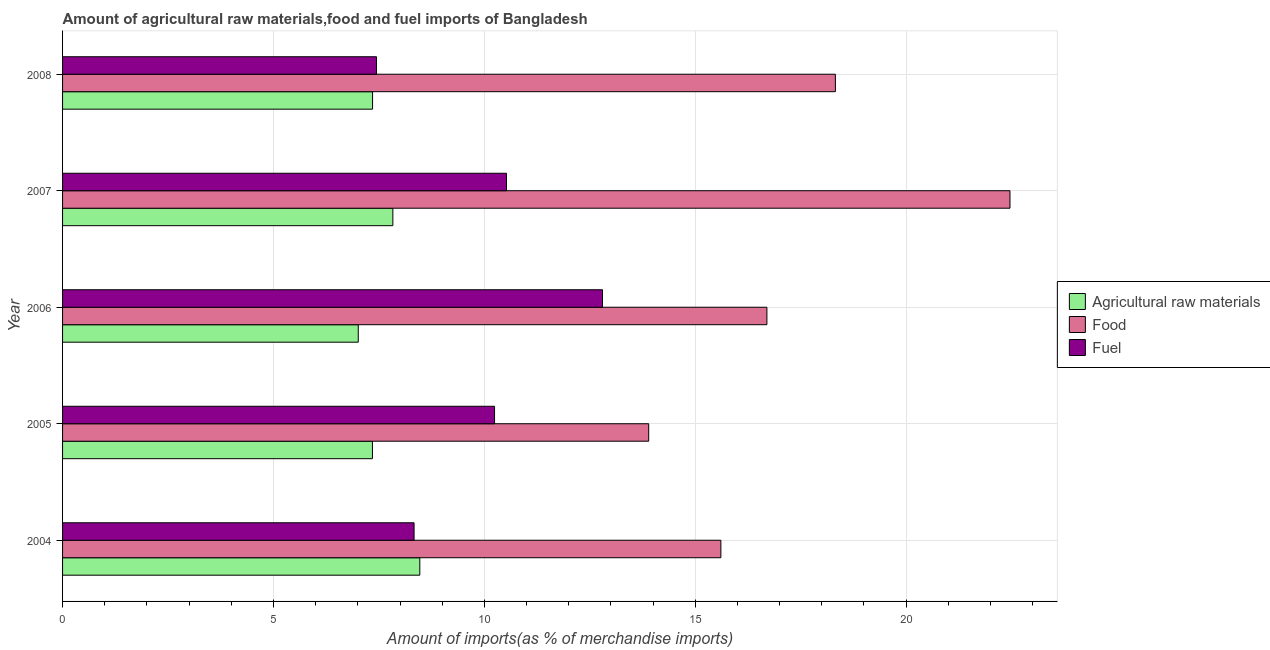How many groups of bars are there?
Provide a short and direct response. 5. Are the number of bars on each tick of the Y-axis equal?
Keep it short and to the point. Yes. How many bars are there on the 5th tick from the top?
Your response must be concise. 3. How many bars are there on the 2nd tick from the bottom?
Provide a short and direct response. 3. What is the label of the 2nd group of bars from the top?
Your response must be concise. 2007. What is the percentage of fuel imports in 2005?
Offer a terse response. 10.24. Across all years, what is the maximum percentage of food imports?
Offer a terse response. 22.46. Across all years, what is the minimum percentage of fuel imports?
Ensure brevity in your answer.  7.44. In which year was the percentage of raw materials imports maximum?
Provide a short and direct response. 2004. What is the total percentage of raw materials imports in the graph?
Keep it short and to the point. 38.01. What is the difference between the percentage of fuel imports in 2005 and that in 2008?
Make the answer very short. 2.8. What is the difference between the percentage of fuel imports in 2004 and the percentage of food imports in 2008?
Provide a succinct answer. -9.99. What is the average percentage of raw materials imports per year?
Your response must be concise. 7.6. In the year 2005, what is the difference between the percentage of fuel imports and percentage of raw materials imports?
Ensure brevity in your answer.  2.9. What is the ratio of the percentage of fuel imports in 2005 to that in 2008?
Your response must be concise. 1.38. Is the difference between the percentage of food imports in 2005 and 2008 greater than the difference between the percentage of fuel imports in 2005 and 2008?
Provide a succinct answer. No. What is the difference between the highest and the second highest percentage of fuel imports?
Provide a short and direct response. 2.28. What is the difference between the highest and the lowest percentage of raw materials imports?
Ensure brevity in your answer.  1.46. In how many years, is the percentage of fuel imports greater than the average percentage of fuel imports taken over all years?
Provide a short and direct response. 3. Is the sum of the percentage of raw materials imports in 2005 and 2008 greater than the maximum percentage of fuel imports across all years?
Keep it short and to the point. Yes. What does the 2nd bar from the top in 2007 represents?
Ensure brevity in your answer.  Food. What does the 2nd bar from the bottom in 2008 represents?
Provide a short and direct response. Food. Is it the case that in every year, the sum of the percentage of raw materials imports and percentage of food imports is greater than the percentage of fuel imports?
Offer a very short reply. Yes. What is the difference between two consecutive major ticks on the X-axis?
Provide a short and direct response. 5. Does the graph contain any zero values?
Make the answer very short. No. Does the graph contain grids?
Make the answer very short. Yes. How are the legend labels stacked?
Your answer should be compact. Vertical. What is the title of the graph?
Your answer should be very brief. Amount of agricultural raw materials,food and fuel imports of Bangladesh. Does "Gaseous fuel" appear as one of the legend labels in the graph?
Your response must be concise. No. What is the label or title of the X-axis?
Give a very brief answer. Amount of imports(as % of merchandise imports). What is the Amount of imports(as % of merchandise imports) in Agricultural raw materials in 2004?
Your answer should be compact. 8.47. What is the Amount of imports(as % of merchandise imports) of Food in 2004?
Offer a very short reply. 15.61. What is the Amount of imports(as % of merchandise imports) of Fuel in 2004?
Offer a terse response. 8.33. What is the Amount of imports(as % of merchandise imports) of Agricultural raw materials in 2005?
Your response must be concise. 7.35. What is the Amount of imports(as % of merchandise imports) in Food in 2005?
Make the answer very short. 13.9. What is the Amount of imports(as % of merchandise imports) in Fuel in 2005?
Provide a short and direct response. 10.24. What is the Amount of imports(as % of merchandise imports) in Agricultural raw materials in 2006?
Provide a short and direct response. 7.01. What is the Amount of imports(as % of merchandise imports) in Food in 2006?
Your answer should be compact. 16.7. What is the Amount of imports(as % of merchandise imports) in Fuel in 2006?
Offer a terse response. 12.8. What is the Amount of imports(as % of merchandise imports) in Agricultural raw materials in 2007?
Offer a terse response. 7.83. What is the Amount of imports(as % of merchandise imports) in Food in 2007?
Make the answer very short. 22.46. What is the Amount of imports(as % of merchandise imports) of Fuel in 2007?
Offer a very short reply. 10.52. What is the Amount of imports(as % of merchandise imports) in Agricultural raw materials in 2008?
Your answer should be very brief. 7.35. What is the Amount of imports(as % of merchandise imports) of Food in 2008?
Provide a succinct answer. 18.32. What is the Amount of imports(as % of merchandise imports) of Fuel in 2008?
Ensure brevity in your answer.  7.44. Across all years, what is the maximum Amount of imports(as % of merchandise imports) in Agricultural raw materials?
Offer a terse response. 8.47. Across all years, what is the maximum Amount of imports(as % of merchandise imports) in Food?
Your answer should be very brief. 22.46. Across all years, what is the maximum Amount of imports(as % of merchandise imports) in Fuel?
Your response must be concise. 12.8. Across all years, what is the minimum Amount of imports(as % of merchandise imports) in Agricultural raw materials?
Keep it short and to the point. 7.01. Across all years, what is the minimum Amount of imports(as % of merchandise imports) in Food?
Your answer should be very brief. 13.9. Across all years, what is the minimum Amount of imports(as % of merchandise imports) of Fuel?
Your response must be concise. 7.44. What is the total Amount of imports(as % of merchandise imports) of Agricultural raw materials in the graph?
Provide a succinct answer. 38.01. What is the total Amount of imports(as % of merchandise imports) of Food in the graph?
Provide a succinct answer. 86.99. What is the total Amount of imports(as % of merchandise imports) of Fuel in the graph?
Offer a very short reply. 49.34. What is the difference between the Amount of imports(as % of merchandise imports) of Agricultural raw materials in 2004 and that in 2005?
Give a very brief answer. 1.12. What is the difference between the Amount of imports(as % of merchandise imports) of Food in 2004 and that in 2005?
Give a very brief answer. 1.71. What is the difference between the Amount of imports(as % of merchandise imports) of Fuel in 2004 and that in 2005?
Provide a short and direct response. -1.91. What is the difference between the Amount of imports(as % of merchandise imports) of Agricultural raw materials in 2004 and that in 2006?
Provide a short and direct response. 1.46. What is the difference between the Amount of imports(as % of merchandise imports) in Food in 2004 and that in 2006?
Offer a terse response. -1.09. What is the difference between the Amount of imports(as % of merchandise imports) of Fuel in 2004 and that in 2006?
Offer a very short reply. -4.47. What is the difference between the Amount of imports(as % of merchandise imports) in Agricultural raw materials in 2004 and that in 2007?
Your response must be concise. 0.64. What is the difference between the Amount of imports(as % of merchandise imports) of Food in 2004 and that in 2007?
Ensure brevity in your answer.  -6.85. What is the difference between the Amount of imports(as % of merchandise imports) of Fuel in 2004 and that in 2007?
Give a very brief answer. -2.19. What is the difference between the Amount of imports(as % of merchandise imports) in Agricultural raw materials in 2004 and that in 2008?
Offer a very short reply. 1.12. What is the difference between the Amount of imports(as % of merchandise imports) in Food in 2004 and that in 2008?
Give a very brief answer. -2.71. What is the difference between the Amount of imports(as % of merchandise imports) in Fuel in 2004 and that in 2008?
Ensure brevity in your answer.  0.89. What is the difference between the Amount of imports(as % of merchandise imports) of Agricultural raw materials in 2005 and that in 2006?
Offer a terse response. 0.34. What is the difference between the Amount of imports(as % of merchandise imports) in Food in 2005 and that in 2006?
Give a very brief answer. -2.8. What is the difference between the Amount of imports(as % of merchandise imports) in Fuel in 2005 and that in 2006?
Keep it short and to the point. -2.56. What is the difference between the Amount of imports(as % of merchandise imports) in Agricultural raw materials in 2005 and that in 2007?
Your answer should be compact. -0.48. What is the difference between the Amount of imports(as % of merchandise imports) of Food in 2005 and that in 2007?
Provide a succinct answer. -8.57. What is the difference between the Amount of imports(as % of merchandise imports) in Fuel in 2005 and that in 2007?
Give a very brief answer. -0.28. What is the difference between the Amount of imports(as % of merchandise imports) in Agricultural raw materials in 2005 and that in 2008?
Provide a succinct answer. -0. What is the difference between the Amount of imports(as % of merchandise imports) in Food in 2005 and that in 2008?
Your answer should be very brief. -4.43. What is the difference between the Amount of imports(as % of merchandise imports) in Fuel in 2005 and that in 2008?
Make the answer very short. 2.8. What is the difference between the Amount of imports(as % of merchandise imports) of Agricultural raw materials in 2006 and that in 2007?
Your answer should be compact. -0.82. What is the difference between the Amount of imports(as % of merchandise imports) of Food in 2006 and that in 2007?
Provide a succinct answer. -5.76. What is the difference between the Amount of imports(as % of merchandise imports) in Fuel in 2006 and that in 2007?
Your answer should be compact. 2.28. What is the difference between the Amount of imports(as % of merchandise imports) of Agricultural raw materials in 2006 and that in 2008?
Provide a short and direct response. -0.34. What is the difference between the Amount of imports(as % of merchandise imports) in Food in 2006 and that in 2008?
Keep it short and to the point. -1.62. What is the difference between the Amount of imports(as % of merchandise imports) in Fuel in 2006 and that in 2008?
Your answer should be compact. 5.36. What is the difference between the Amount of imports(as % of merchandise imports) of Agricultural raw materials in 2007 and that in 2008?
Your response must be concise. 0.48. What is the difference between the Amount of imports(as % of merchandise imports) of Food in 2007 and that in 2008?
Offer a terse response. 4.14. What is the difference between the Amount of imports(as % of merchandise imports) in Fuel in 2007 and that in 2008?
Ensure brevity in your answer.  3.08. What is the difference between the Amount of imports(as % of merchandise imports) of Agricultural raw materials in 2004 and the Amount of imports(as % of merchandise imports) of Food in 2005?
Offer a terse response. -5.43. What is the difference between the Amount of imports(as % of merchandise imports) of Agricultural raw materials in 2004 and the Amount of imports(as % of merchandise imports) of Fuel in 2005?
Your answer should be compact. -1.77. What is the difference between the Amount of imports(as % of merchandise imports) of Food in 2004 and the Amount of imports(as % of merchandise imports) of Fuel in 2005?
Give a very brief answer. 5.37. What is the difference between the Amount of imports(as % of merchandise imports) in Agricultural raw materials in 2004 and the Amount of imports(as % of merchandise imports) in Food in 2006?
Your answer should be compact. -8.23. What is the difference between the Amount of imports(as % of merchandise imports) in Agricultural raw materials in 2004 and the Amount of imports(as % of merchandise imports) in Fuel in 2006?
Provide a succinct answer. -4.33. What is the difference between the Amount of imports(as % of merchandise imports) of Food in 2004 and the Amount of imports(as % of merchandise imports) of Fuel in 2006?
Your response must be concise. 2.81. What is the difference between the Amount of imports(as % of merchandise imports) of Agricultural raw materials in 2004 and the Amount of imports(as % of merchandise imports) of Food in 2007?
Keep it short and to the point. -13.99. What is the difference between the Amount of imports(as % of merchandise imports) in Agricultural raw materials in 2004 and the Amount of imports(as % of merchandise imports) in Fuel in 2007?
Keep it short and to the point. -2.06. What is the difference between the Amount of imports(as % of merchandise imports) in Food in 2004 and the Amount of imports(as % of merchandise imports) in Fuel in 2007?
Your response must be concise. 5.08. What is the difference between the Amount of imports(as % of merchandise imports) of Agricultural raw materials in 2004 and the Amount of imports(as % of merchandise imports) of Food in 2008?
Your response must be concise. -9.85. What is the difference between the Amount of imports(as % of merchandise imports) of Agricultural raw materials in 2004 and the Amount of imports(as % of merchandise imports) of Fuel in 2008?
Give a very brief answer. 1.03. What is the difference between the Amount of imports(as % of merchandise imports) of Food in 2004 and the Amount of imports(as % of merchandise imports) of Fuel in 2008?
Make the answer very short. 8.16. What is the difference between the Amount of imports(as % of merchandise imports) of Agricultural raw materials in 2005 and the Amount of imports(as % of merchandise imports) of Food in 2006?
Give a very brief answer. -9.35. What is the difference between the Amount of imports(as % of merchandise imports) of Agricultural raw materials in 2005 and the Amount of imports(as % of merchandise imports) of Fuel in 2006?
Keep it short and to the point. -5.45. What is the difference between the Amount of imports(as % of merchandise imports) of Food in 2005 and the Amount of imports(as % of merchandise imports) of Fuel in 2006?
Ensure brevity in your answer.  1.09. What is the difference between the Amount of imports(as % of merchandise imports) of Agricultural raw materials in 2005 and the Amount of imports(as % of merchandise imports) of Food in 2007?
Offer a very short reply. -15.11. What is the difference between the Amount of imports(as % of merchandise imports) of Agricultural raw materials in 2005 and the Amount of imports(as % of merchandise imports) of Fuel in 2007?
Your answer should be very brief. -3.18. What is the difference between the Amount of imports(as % of merchandise imports) in Food in 2005 and the Amount of imports(as % of merchandise imports) in Fuel in 2007?
Offer a terse response. 3.37. What is the difference between the Amount of imports(as % of merchandise imports) of Agricultural raw materials in 2005 and the Amount of imports(as % of merchandise imports) of Food in 2008?
Keep it short and to the point. -10.98. What is the difference between the Amount of imports(as % of merchandise imports) in Agricultural raw materials in 2005 and the Amount of imports(as % of merchandise imports) in Fuel in 2008?
Offer a very short reply. -0.1. What is the difference between the Amount of imports(as % of merchandise imports) of Food in 2005 and the Amount of imports(as % of merchandise imports) of Fuel in 2008?
Offer a very short reply. 6.45. What is the difference between the Amount of imports(as % of merchandise imports) in Agricultural raw materials in 2006 and the Amount of imports(as % of merchandise imports) in Food in 2007?
Offer a very short reply. -15.45. What is the difference between the Amount of imports(as % of merchandise imports) in Agricultural raw materials in 2006 and the Amount of imports(as % of merchandise imports) in Fuel in 2007?
Offer a very short reply. -3.51. What is the difference between the Amount of imports(as % of merchandise imports) of Food in 2006 and the Amount of imports(as % of merchandise imports) of Fuel in 2007?
Your response must be concise. 6.17. What is the difference between the Amount of imports(as % of merchandise imports) in Agricultural raw materials in 2006 and the Amount of imports(as % of merchandise imports) in Food in 2008?
Provide a succinct answer. -11.31. What is the difference between the Amount of imports(as % of merchandise imports) of Agricultural raw materials in 2006 and the Amount of imports(as % of merchandise imports) of Fuel in 2008?
Give a very brief answer. -0.43. What is the difference between the Amount of imports(as % of merchandise imports) of Food in 2006 and the Amount of imports(as % of merchandise imports) of Fuel in 2008?
Make the answer very short. 9.26. What is the difference between the Amount of imports(as % of merchandise imports) in Agricultural raw materials in 2007 and the Amount of imports(as % of merchandise imports) in Food in 2008?
Ensure brevity in your answer.  -10.49. What is the difference between the Amount of imports(as % of merchandise imports) in Agricultural raw materials in 2007 and the Amount of imports(as % of merchandise imports) in Fuel in 2008?
Make the answer very short. 0.39. What is the difference between the Amount of imports(as % of merchandise imports) in Food in 2007 and the Amount of imports(as % of merchandise imports) in Fuel in 2008?
Your answer should be very brief. 15.02. What is the average Amount of imports(as % of merchandise imports) of Agricultural raw materials per year?
Your answer should be very brief. 7.6. What is the average Amount of imports(as % of merchandise imports) in Food per year?
Provide a succinct answer. 17.4. What is the average Amount of imports(as % of merchandise imports) in Fuel per year?
Your response must be concise. 9.87. In the year 2004, what is the difference between the Amount of imports(as % of merchandise imports) in Agricultural raw materials and Amount of imports(as % of merchandise imports) in Food?
Give a very brief answer. -7.14. In the year 2004, what is the difference between the Amount of imports(as % of merchandise imports) of Agricultural raw materials and Amount of imports(as % of merchandise imports) of Fuel?
Ensure brevity in your answer.  0.14. In the year 2004, what is the difference between the Amount of imports(as % of merchandise imports) in Food and Amount of imports(as % of merchandise imports) in Fuel?
Offer a very short reply. 7.27. In the year 2005, what is the difference between the Amount of imports(as % of merchandise imports) of Agricultural raw materials and Amount of imports(as % of merchandise imports) of Food?
Offer a terse response. -6.55. In the year 2005, what is the difference between the Amount of imports(as % of merchandise imports) of Agricultural raw materials and Amount of imports(as % of merchandise imports) of Fuel?
Offer a terse response. -2.89. In the year 2005, what is the difference between the Amount of imports(as % of merchandise imports) of Food and Amount of imports(as % of merchandise imports) of Fuel?
Your response must be concise. 3.65. In the year 2006, what is the difference between the Amount of imports(as % of merchandise imports) in Agricultural raw materials and Amount of imports(as % of merchandise imports) in Food?
Offer a very short reply. -9.69. In the year 2006, what is the difference between the Amount of imports(as % of merchandise imports) of Agricultural raw materials and Amount of imports(as % of merchandise imports) of Fuel?
Your answer should be compact. -5.79. In the year 2006, what is the difference between the Amount of imports(as % of merchandise imports) in Food and Amount of imports(as % of merchandise imports) in Fuel?
Your answer should be compact. 3.9. In the year 2007, what is the difference between the Amount of imports(as % of merchandise imports) of Agricultural raw materials and Amount of imports(as % of merchandise imports) of Food?
Provide a succinct answer. -14.63. In the year 2007, what is the difference between the Amount of imports(as % of merchandise imports) in Agricultural raw materials and Amount of imports(as % of merchandise imports) in Fuel?
Offer a terse response. -2.69. In the year 2007, what is the difference between the Amount of imports(as % of merchandise imports) in Food and Amount of imports(as % of merchandise imports) in Fuel?
Keep it short and to the point. 11.94. In the year 2008, what is the difference between the Amount of imports(as % of merchandise imports) of Agricultural raw materials and Amount of imports(as % of merchandise imports) of Food?
Your response must be concise. -10.97. In the year 2008, what is the difference between the Amount of imports(as % of merchandise imports) in Agricultural raw materials and Amount of imports(as % of merchandise imports) in Fuel?
Offer a terse response. -0.09. In the year 2008, what is the difference between the Amount of imports(as % of merchandise imports) of Food and Amount of imports(as % of merchandise imports) of Fuel?
Give a very brief answer. 10.88. What is the ratio of the Amount of imports(as % of merchandise imports) in Agricultural raw materials in 2004 to that in 2005?
Your answer should be compact. 1.15. What is the ratio of the Amount of imports(as % of merchandise imports) of Food in 2004 to that in 2005?
Make the answer very short. 1.12. What is the ratio of the Amount of imports(as % of merchandise imports) of Fuel in 2004 to that in 2005?
Your response must be concise. 0.81. What is the ratio of the Amount of imports(as % of merchandise imports) in Agricultural raw materials in 2004 to that in 2006?
Your answer should be compact. 1.21. What is the ratio of the Amount of imports(as % of merchandise imports) in Food in 2004 to that in 2006?
Keep it short and to the point. 0.93. What is the ratio of the Amount of imports(as % of merchandise imports) in Fuel in 2004 to that in 2006?
Your answer should be very brief. 0.65. What is the ratio of the Amount of imports(as % of merchandise imports) of Agricultural raw materials in 2004 to that in 2007?
Your answer should be compact. 1.08. What is the ratio of the Amount of imports(as % of merchandise imports) in Food in 2004 to that in 2007?
Offer a very short reply. 0.69. What is the ratio of the Amount of imports(as % of merchandise imports) of Fuel in 2004 to that in 2007?
Provide a succinct answer. 0.79. What is the ratio of the Amount of imports(as % of merchandise imports) of Agricultural raw materials in 2004 to that in 2008?
Your response must be concise. 1.15. What is the ratio of the Amount of imports(as % of merchandise imports) in Food in 2004 to that in 2008?
Ensure brevity in your answer.  0.85. What is the ratio of the Amount of imports(as % of merchandise imports) in Fuel in 2004 to that in 2008?
Offer a very short reply. 1.12. What is the ratio of the Amount of imports(as % of merchandise imports) of Agricultural raw materials in 2005 to that in 2006?
Provide a short and direct response. 1.05. What is the ratio of the Amount of imports(as % of merchandise imports) of Food in 2005 to that in 2006?
Provide a succinct answer. 0.83. What is the ratio of the Amount of imports(as % of merchandise imports) in Fuel in 2005 to that in 2006?
Ensure brevity in your answer.  0.8. What is the ratio of the Amount of imports(as % of merchandise imports) in Agricultural raw materials in 2005 to that in 2007?
Your answer should be very brief. 0.94. What is the ratio of the Amount of imports(as % of merchandise imports) in Food in 2005 to that in 2007?
Your answer should be very brief. 0.62. What is the ratio of the Amount of imports(as % of merchandise imports) in Fuel in 2005 to that in 2007?
Your answer should be compact. 0.97. What is the ratio of the Amount of imports(as % of merchandise imports) in Food in 2005 to that in 2008?
Provide a short and direct response. 0.76. What is the ratio of the Amount of imports(as % of merchandise imports) in Fuel in 2005 to that in 2008?
Your answer should be very brief. 1.38. What is the ratio of the Amount of imports(as % of merchandise imports) in Agricultural raw materials in 2006 to that in 2007?
Give a very brief answer. 0.9. What is the ratio of the Amount of imports(as % of merchandise imports) of Food in 2006 to that in 2007?
Your answer should be very brief. 0.74. What is the ratio of the Amount of imports(as % of merchandise imports) of Fuel in 2006 to that in 2007?
Keep it short and to the point. 1.22. What is the ratio of the Amount of imports(as % of merchandise imports) of Agricultural raw materials in 2006 to that in 2008?
Offer a terse response. 0.95. What is the ratio of the Amount of imports(as % of merchandise imports) in Food in 2006 to that in 2008?
Provide a short and direct response. 0.91. What is the ratio of the Amount of imports(as % of merchandise imports) in Fuel in 2006 to that in 2008?
Your response must be concise. 1.72. What is the ratio of the Amount of imports(as % of merchandise imports) of Agricultural raw materials in 2007 to that in 2008?
Offer a very short reply. 1.07. What is the ratio of the Amount of imports(as % of merchandise imports) of Food in 2007 to that in 2008?
Ensure brevity in your answer.  1.23. What is the ratio of the Amount of imports(as % of merchandise imports) in Fuel in 2007 to that in 2008?
Offer a terse response. 1.41. What is the difference between the highest and the second highest Amount of imports(as % of merchandise imports) in Agricultural raw materials?
Your answer should be compact. 0.64. What is the difference between the highest and the second highest Amount of imports(as % of merchandise imports) in Food?
Offer a very short reply. 4.14. What is the difference between the highest and the second highest Amount of imports(as % of merchandise imports) in Fuel?
Your response must be concise. 2.28. What is the difference between the highest and the lowest Amount of imports(as % of merchandise imports) in Agricultural raw materials?
Provide a succinct answer. 1.46. What is the difference between the highest and the lowest Amount of imports(as % of merchandise imports) of Food?
Your response must be concise. 8.57. What is the difference between the highest and the lowest Amount of imports(as % of merchandise imports) of Fuel?
Provide a succinct answer. 5.36. 